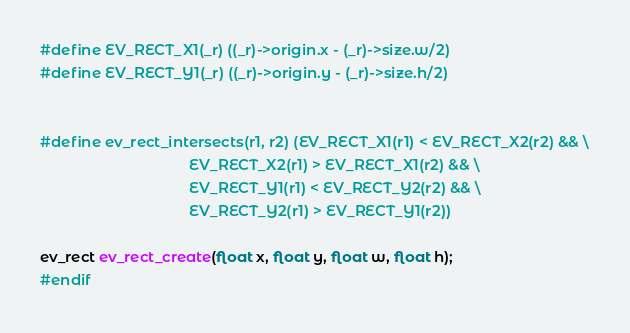Convert code to text. <code><loc_0><loc_0><loc_500><loc_500><_C_>
#define EV_RECT_X1(_r) ((_r)->origin.x - (_r)->size.w/2)
#define EV_RECT_Y1(_r) ((_r)->origin.y - (_r)->size.h/2)


#define ev_rect_intersects(r1, r2) (EV_RECT_X1(r1) < EV_RECT_X2(r2) && \
                                    EV_RECT_X2(r1) > EV_RECT_X1(r2) && \
                                    EV_RECT_Y1(r1) < EV_RECT_Y2(r2) && \
                                    EV_RECT_Y2(r1) > EV_RECT_Y1(r2))

ev_rect ev_rect_create(float x, float y, float w, float h);
#endif
</code> 